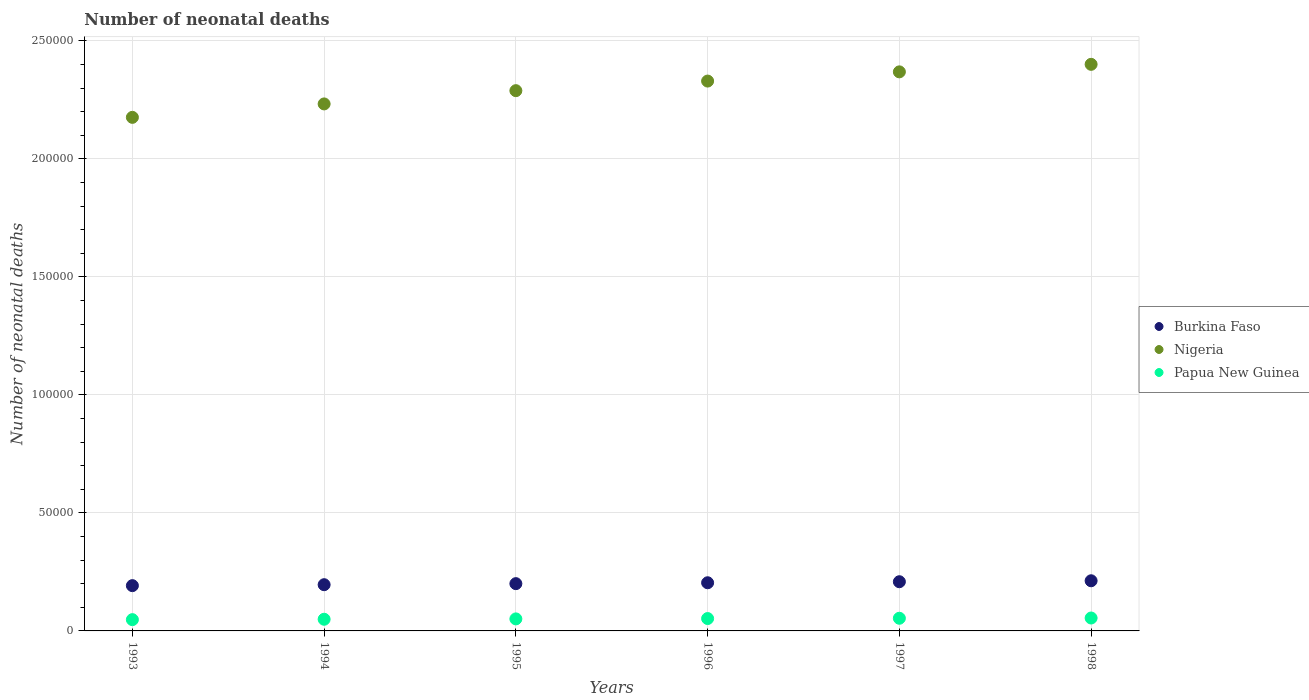How many different coloured dotlines are there?
Offer a terse response. 3. Is the number of dotlines equal to the number of legend labels?
Keep it short and to the point. Yes. What is the number of neonatal deaths in in Nigeria in 1993?
Your response must be concise. 2.18e+05. Across all years, what is the maximum number of neonatal deaths in in Burkina Faso?
Keep it short and to the point. 2.12e+04. Across all years, what is the minimum number of neonatal deaths in in Nigeria?
Offer a very short reply. 2.18e+05. In which year was the number of neonatal deaths in in Burkina Faso minimum?
Your response must be concise. 1993. What is the total number of neonatal deaths in in Papua New Guinea in the graph?
Provide a succinct answer. 3.09e+04. What is the difference between the number of neonatal deaths in in Nigeria in 1997 and that in 1998?
Ensure brevity in your answer.  -3185. What is the difference between the number of neonatal deaths in in Nigeria in 1993 and the number of neonatal deaths in in Papua New Guinea in 1997?
Make the answer very short. 2.12e+05. What is the average number of neonatal deaths in in Nigeria per year?
Keep it short and to the point. 2.30e+05. In the year 1993, what is the difference between the number of neonatal deaths in in Nigeria and number of neonatal deaths in in Papua New Guinea?
Offer a very short reply. 2.13e+05. What is the ratio of the number of neonatal deaths in in Papua New Guinea in 1995 to that in 1997?
Provide a succinct answer. 0.95. Is the number of neonatal deaths in in Burkina Faso in 1995 less than that in 1998?
Your answer should be compact. Yes. Is the difference between the number of neonatal deaths in in Nigeria in 1995 and 1997 greater than the difference between the number of neonatal deaths in in Papua New Guinea in 1995 and 1997?
Provide a short and direct response. No. What is the difference between the highest and the second highest number of neonatal deaths in in Burkina Faso?
Offer a terse response. 403. What is the difference between the highest and the lowest number of neonatal deaths in in Burkina Faso?
Give a very brief answer. 2062. Is the sum of the number of neonatal deaths in in Papua New Guinea in 1994 and 1995 greater than the maximum number of neonatal deaths in in Burkina Faso across all years?
Offer a terse response. No. Does the number of neonatal deaths in in Nigeria monotonically increase over the years?
Make the answer very short. Yes. Is the number of neonatal deaths in in Nigeria strictly greater than the number of neonatal deaths in in Burkina Faso over the years?
Your response must be concise. Yes. Is the number of neonatal deaths in in Papua New Guinea strictly less than the number of neonatal deaths in in Burkina Faso over the years?
Provide a short and direct response. Yes. How many dotlines are there?
Make the answer very short. 3. How many years are there in the graph?
Make the answer very short. 6. Are the values on the major ticks of Y-axis written in scientific E-notation?
Provide a succinct answer. No. Does the graph contain grids?
Make the answer very short. Yes. How many legend labels are there?
Offer a very short reply. 3. What is the title of the graph?
Offer a terse response. Number of neonatal deaths. Does "Madagascar" appear as one of the legend labels in the graph?
Provide a short and direct response. No. What is the label or title of the Y-axis?
Your answer should be very brief. Number of neonatal deaths. What is the Number of neonatal deaths of Burkina Faso in 1993?
Your answer should be very brief. 1.92e+04. What is the Number of neonatal deaths in Nigeria in 1993?
Give a very brief answer. 2.18e+05. What is the Number of neonatal deaths in Papua New Guinea in 1993?
Your answer should be compact. 4776. What is the Number of neonatal deaths in Burkina Faso in 1994?
Your answer should be compact. 1.96e+04. What is the Number of neonatal deaths in Nigeria in 1994?
Provide a short and direct response. 2.23e+05. What is the Number of neonatal deaths in Papua New Guinea in 1994?
Ensure brevity in your answer.  4942. What is the Number of neonatal deaths in Burkina Faso in 1995?
Offer a very short reply. 2.00e+04. What is the Number of neonatal deaths of Nigeria in 1995?
Your answer should be very brief. 2.29e+05. What is the Number of neonatal deaths of Papua New Guinea in 1995?
Provide a succinct answer. 5095. What is the Number of neonatal deaths of Burkina Faso in 1996?
Keep it short and to the point. 2.04e+04. What is the Number of neonatal deaths in Nigeria in 1996?
Keep it short and to the point. 2.33e+05. What is the Number of neonatal deaths of Papua New Guinea in 1996?
Keep it short and to the point. 5244. What is the Number of neonatal deaths in Burkina Faso in 1997?
Your response must be concise. 2.08e+04. What is the Number of neonatal deaths of Nigeria in 1997?
Make the answer very short. 2.37e+05. What is the Number of neonatal deaths of Papua New Guinea in 1997?
Provide a short and direct response. 5367. What is the Number of neonatal deaths in Burkina Faso in 1998?
Your response must be concise. 2.12e+04. What is the Number of neonatal deaths in Nigeria in 1998?
Keep it short and to the point. 2.40e+05. What is the Number of neonatal deaths of Papua New Guinea in 1998?
Offer a very short reply. 5471. Across all years, what is the maximum Number of neonatal deaths of Burkina Faso?
Your answer should be compact. 2.12e+04. Across all years, what is the maximum Number of neonatal deaths in Nigeria?
Give a very brief answer. 2.40e+05. Across all years, what is the maximum Number of neonatal deaths of Papua New Guinea?
Keep it short and to the point. 5471. Across all years, what is the minimum Number of neonatal deaths in Burkina Faso?
Give a very brief answer. 1.92e+04. Across all years, what is the minimum Number of neonatal deaths of Nigeria?
Make the answer very short. 2.18e+05. Across all years, what is the minimum Number of neonatal deaths in Papua New Guinea?
Give a very brief answer. 4776. What is the total Number of neonatal deaths in Burkina Faso in the graph?
Make the answer very short. 1.21e+05. What is the total Number of neonatal deaths of Nigeria in the graph?
Your answer should be compact. 1.38e+06. What is the total Number of neonatal deaths in Papua New Guinea in the graph?
Offer a very short reply. 3.09e+04. What is the difference between the Number of neonatal deaths of Burkina Faso in 1993 and that in 1994?
Your answer should be compact. -399. What is the difference between the Number of neonatal deaths in Nigeria in 1993 and that in 1994?
Offer a terse response. -5689. What is the difference between the Number of neonatal deaths in Papua New Guinea in 1993 and that in 1994?
Keep it short and to the point. -166. What is the difference between the Number of neonatal deaths in Burkina Faso in 1993 and that in 1995?
Make the answer very short. -844. What is the difference between the Number of neonatal deaths of Nigeria in 1993 and that in 1995?
Your answer should be compact. -1.13e+04. What is the difference between the Number of neonatal deaths of Papua New Guinea in 1993 and that in 1995?
Make the answer very short. -319. What is the difference between the Number of neonatal deaths of Burkina Faso in 1993 and that in 1996?
Your answer should be compact. -1220. What is the difference between the Number of neonatal deaths in Nigeria in 1993 and that in 1996?
Your answer should be very brief. -1.54e+04. What is the difference between the Number of neonatal deaths in Papua New Guinea in 1993 and that in 1996?
Provide a short and direct response. -468. What is the difference between the Number of neonatal deaths in Burkina Faso in 1993 and that in 1997?
Give a very brief answer. -1659. What is the difference between the Number of neonatal deaths in Nigeria in 1993 and that in 1997?
Offer a very short reply. -1.93e+04. What is the difference between the Number of neonatal deaths of Papua New Guinea in 1993 and that in 1997?
Ensure brevity in your answer.  -591. What is the difference between the Number of neonatal deaths in Burkina Faso in 1993 and that in 1998?
Keep it short and to the point. -2062. What is the difference between the Number of neonatal deaths of Nigeria in 1993 and that in 1998?
Your answer should be compact. -2.25e+04. What is the difference between the Number of neonatal deaths in Papua New Guinea in 1993 and that in 1998?
Make the answer very short. -695. What is the difference between the Number of neonatal deaths in Burkina Faso in 1994 and that in 1995?
Provide a succinct answer. -445. What is the difference between the Number of neonatal deaths in Nigeria in 1994 and that in 1995?
Your response must be concise. -5616. What is the difference between the Number of neonatal deaths of Papua New Guinea in 1994 and that in 1995?
Keep it short and to the point. -153. What is the difference between the Number of neonatal deaths in Burkina Faso in 1994 and that in 1996?
Provide a short and direct response. -821. What is the difference between the Number of neonatal deaths in Nigeria in 1994 and that in 1996?
Keep it short and to the point. -9683. What is the difference between the Number of neonatal deaths of Papua New Guinea in 1994 and that in 1996?
Provide a short and direct response. -302. What is the difference between the Number of neonatal deaths of Burkina Faso in 1994 and that in 1997?
Make the answer very short. -1260. What is the difference between the Number of neonatal deaths in Nigeria in 1994 and that in 1997?
Your answer should be compact. -1.36e+04. What is the difference between the Number of neonatal deaths in Papua New Guinea in 1994 and that in 1997?
Keep it short and to the point. -425. What is the difference between the Number of neonatal deaths in Burkina Faso in 1994 and that in 1998?
Ensure brevity in your answer.  -1663. What is the difference between the Number of neonatal deaths of Nigeria in 1994 and that in 1998?
Keep it short and to the point. -1.68e+04. What is the difference between the Number of neonatal deaths in Papua New Guinea in 1994 and that in 1998?
Your answer should be compact. -529. What is the difference between the Number of neonatal deaths in Burkina Faso in 1995 and that in 1996?
Offer a terse response. -376. What is the difference between the Number of neonatal deaths of Nigeria in 1995 and that in 1996?
Offer a terse response. -4067. What is the difference between the Number of neonatal deaths of Papua New Guinea in 1995 and that in 1996?
Make the answer very short. -149. What is the difference between the Number of neonatal deaths of Burkina Faso in 1995 and that in 1997?
Keep it short and to the point. -815. What is the difference between the Number of neonatal deaths in Nigeria in 1995 and that in 1997?
Ensure brevity in your answer.  -7971. What is the difference between the Number of neonatal deaths of Papua New Guinea in 1995 and that in 1997?
Provide a short and direct response. -272. What is the difference between the Number of neonatal deaths of Burkina Faso in 1995 and that in 1998?
Your response must be concise. -1218. What is the difference between the Number of neonatal deaths in Nigeria in 1995 and that in 1998?
Your response must be concise. -1.12e+04. What is the difference between the Number of neonatal deaths of Papua New Guinea in 1995 and that in 1998?
Make the answer very short. -376. What is the difference between the Number of neonatal deaths of Burkina Faso in 1996 and that in 1997?
Ensure brevity in your answer.  -439. What is the difference between the Number of neonatal deaths in Nigeria in 1996 and that in 1997?
Your response must be concise. -3904. What is the difference between the Number of neonatal deaths in Papua New Guinea in 1996 and that in 1997?
Your answer should be compact. -123. What is the difference between the Number of neonatal deaths in Burkina Faso in 1996 and that in 1998?
Offer a terse response. -842. What is the difference between the Number of neonatal deaths of Nigeria in 1996 and that in 1998?
Ensure brevity in your answer.  -7089. What is the difference between the Number of neonatal deaths in Papua New Guinea in 1996 and that in 1998?
Your response must be concise. -227. What is the difference between the Number of neonatal deaths of Burkina Faso in 1997 and that in 1998?
Your answer should be compact. -403. What is the difference between the Number of neonatal deaths of Nigeria in 1997 and that in 1998?
Give a very brief answer. -3185. What is the difference between the Number of neonatal deaths of Papua New Guinea in 1997 and that in 1998?
Offer a terse response. -104. What is the difference between the Number of neonatal deaths in Burkina Faso in 1993 and the Number of neonatal deaths in Nigeria in 1994?
Offer a very short reply. -2.04e+05. What is the difference between the Number of neonatal deaths in Burkina Faso in 1993 and the Number of neonatal deaths in Papua New Guinea in 1994?
Provide a succinct answer. 1.42e+04. What is the difference between the Number of neonatal deaths of Nigeria in 1993 and the Number of neonatal deaths of Papua New Guinea in 1994?
Offer a very short reply. 2.13e+05. What is the difference between the Number of neonatal deaths in Burkina Faso in 1993 and the Number of neonatal deaths in Nigeria in 1995?
Keep it short and to the point. -2.10e+05. What is the difference between the Number of neonatal deaths of Burkina Faso in 1993 and the Number of neonatal deaths of Papua New Guinea in 1995?
Provide a short and direct response. 1.41e+04. What is the difference between the Number of neonatal deaths of Nigeria in 1993 and the Number of neonatal deaths of Papua New Guinea in 1995?
Make the answer very short. 2.13e+05. What is the difference between the Number of neonatal deaths in Burkina Faso in 1993 and the Number of neonatal deaths in Nigeria in 1996?
Make the answer very short. -2.14e+05. What is the difference between the Number of neonatal deaths in Burkina Faso in 1993 and the Number of neonatal deaths in Papua New Guinea in 1996?
Give a very brief answer. 1.39e+04. What is the difference between the Number of neonatal deaths of Nigeria in 1993 and the Number of neonatal deaths of Papua New Guinea in 1996?
Offer a terse response. 2.12e+05. What is the difference between the Number of neonatal deaths of Burkina Faso in 1993 and the Number of neonatal deaths of Nigeria in 1997?
Make the answer very short. -2.18e+05. What is the difference between the Number of neonatal deaths in Burkina Faso in 1993 and the Number of neonatal deaths in Papua New Guinea in 1997?
Give a very brief answer. 1.38e+04. What is the difference between the Number of neonatal deaths of Nigeria in 1993 and the Number of neonatal deaths of Papua New Guinea in 1997?
Provide a short and direct response. 2.12e+05. What is the difference between the Number of neonatal deaths of Burkina Faso in 1993 and the Number of neonatal deaths of Nigeria in 1998?
Your answer should be very brief. -2.21e+05. What is the difference between the Number of neonatal deaths of Burkina Faso in 1993 and the Number of neonatal deaths of Papua New Guinea in 1998?
Provide a succinct answer. 1.37e+04. What is the difference between the Number of neonatal deaths in Nigeria in 1993 and the Number of neonatal deaths in Papua New Guinea in 1998?
Make the answer very short. 2.12e+05. What is the difference between the Number of neonatal deaths of Burkina Faso in 1994 and the Number of neonatal deaths of Nigeria in 1995?
Offer a very short reply. -2.09e+05. What is the difference between the Number of neonatal deaths in Burkina Faso in 1994 and the Number of neonatal deaths in Papua New Guinea in 1995?
Your response must be concise. 1.45e+04. What is the difference between the Number of neonatal deaths of Nigeria in 1994 and the Number of neonatal deaths of Papua New Guinea in 1995?
Keep it short and to the point. 2.18e+05. What is the difference between the Number of neonatal deaths in Burkina Faso in 1994 and the Number of neonatal deaths in Nigeria in 1996?
Your answer should be compact. -2.13e+05. What is the difference between the Number of neonatal deaths of Burkina Faso in 1994 and the Number of neonatal deaths of Papua New Guinea in 1996?
Provide a succinct answer. 1.43e+04. What is the difference between the Number of neonatal deaths in Nigeria in 1994 and the Number of neonatal deaths in Papua New Guinea in 1996?
Give a very brief answer. 2.18e+05. What is the difference between the Number of neonatal deaths in Burkina Faso in 1994 and the Number of neonatal deaths in Nigeria in 1997?
Give a very brief answer. -2.17e+05. What is the difference between the Number of neonatal deaths of Burkina Faso in 1994 and the Number of neonatal deaths of Papua New Guinea in 1997?
Ensure brevity in your answer.  1.42e+04. What is the difference between the Number of neonatal deaths in Nigeria in 1994 and the Number of neonatal deaths in Papua New Guinea in 1997?
Provide a short and direct response. 2.18e+05. What is the difference between the Number of neonatal deaths of Burkina Faso in 1994 and the Number of neonatal deaths of Nigeria in 1998?
Provide a short and direct response. -2.20e+05. What is the difference between the Number of neonatal deaths of Burkina Faso in 1994 and the Number of neonatal deaths of Papua New Guinea in 1998?
Offer a very short reply. 1.41e+04. What is the difference between the Number of neonatal deaths of Nigeria in 1994 and the Number of neonatal deaths of Papua New Guinea in 1998?
Ensure brevity in your answer.  2.18e+05. What is the difference between the Number of neonatal deaths of Burkina Faso in 1995 and the Number of neonatal deaths of Nigeria in 1996?
Give a very brief answer. -2.13e+05. What is the difference between the Number of neonatal deaths of Burkina Faso in 1995 and the Number of neonatal deaths of Papua New Guinea in 1996?
Ensure brevity in your answer.  1.48e+04. What is the difference between the Number of neonatal deaths in Nigeria in 1995 and the Number of neonatal deaths in Papua New Guinea in 1996?
Give a very brief answer. 2.24e+05. What is the difference between the Number of neonatal deaths in Burkina Faso in 1995 and the Number of neonatal deaths in Nigeria in 1997?
Make the answer very short. -2.17e+05. What is the difference between the Number of neonatal deaths in Burkina Faso in 1995 and the Number of neonatal deaths in Papua New Guinea in 1997?
Your response must be concise. 1.47e+04. What is the difference between the Number of neonatal deaths in Nigeria in 1995 and the Number of neonatal deaths in Papua New Guinea in 1997?
Make the answer very short. 2.24e+05. What is the difference between the Number of neonatal deaths of Burkina Faso in 1995 and the Number of neonatal deaths of Nigeria in 1998?
Make the answer very short. -2.20e+05. What is the difference between the Number of neonatal deaths of Burkina Faso in 1995 and the Number of neonatal deaths of Papua New Guinea in 1998?
Give a very brief answer. 1.46e+04. What is the difference between the Number of neonatal deaths in Nigeria in 1995 and the Number of neonatal deaths in Papua New Guinea in 1998?
Ensure brevity in your answer.  2.23e+05. What is the difference between the Number of neonatal deaths of Burkina Faso in 1996 and the Number of neonatal deaths of Nigeria in 1997?
Keep it short and to the point. -2.16e+05. What is the difference between the Number of neonatal deaths in Burkina Faso in 1996 and the Number of neonatal deaths in Papua New Guinea in 1997?
Make the answer very short. 1.50e+04. What is the difference between the Number of neonatal deaths of Nigeria in 1996 and the Number of neonatal deaths of Papua New Guinea in 1997?
Your answer should be compact. 2.28e+05. What is the difference between the Number of neonatal deaths of Burkina Faso in 1996 and the Number of neonatal deaths of Nigeria in 1998?
Keep it short and to the point. -2.20e+05. What is the difference between the Number of neonatal deaths of Burkina Faso in 1996 and the Number of neonatal deaths of Papua New Guinea in 1998?
Provide a short and direct response. 1.49e+04. What is the difference between the Number of neonatal deaths in Nigeria in 1996 and the Number of neonatal deaths in Papua New Guinea in 1998?
Keep it short and to the point. 2.28e+05. What is the difference between the Number of neonatal deaths of Burkina Faso in 1997 and the Number of neonatal deaths of Nigeria in 1998?
Make the answer very short. -2.19e+05. What is the difference between the Number of neonatal deaths of Burkina Faso in 1997 and the Number of neonatal deaths of Papua New Guinea in 1998?
Give a very brief answer. 1.54e+04. What is the difference between the Number of neonatal deaths of Nigeria in 1997 and the Number of neonatal deaths of Papua New Guinea in 1998?
Offer a terse response. 2.31e+05. What is the average Number of neonatal deaths of Burkina Faso per year?
Your response must be concise. 2.02e+04. What is the average Number of neonatal deaths in Nigeria per year?
Provide a succinct answer. 2.30e+05. What is the average Number of neonatal deaths in Papua New Guinea per year?
Provide a short and direct response. 5149.17. In the year 1993, what is the difference between the Number of neonatal deaths of Burkina Faso and Number of neonatal deaths of Nigeria?
Offer a very short reply. -1.98e+05. In the year 1993, what is the difference between the Number of neonatal deaths in Burkina Faso and Number of neonatal deaths in Papua New Guinea?
Give a very brief answer. 1.44e+04. In the year 1993, what is the difference between the Number of neonatal deaths in Nigeria and Number of neonatal deaths in Papua New Guinea?
Your answer should be very brief. 2.13e+05. In the year 1994, what is the difference between the Number of neonatal deaths of Burkina Faso and Number of neonatal deaths of Nigeria?
Provide a succinct answer. -2.04e+05. In the year 1994, what is the difference between the Number of neonatal deaths in Burkina Faso and Number of neonatal deaths in Papua New Guinea?
Keep it short and to the point. 1.46e+04. In the year 1994, what is the difference between the Number of neonatal deaths of Nigeria and Number of neonatal deaths of Papua New Guinea?
Give a very brief answer. 2.18e+05. In the year 1995, what is the difference between the Number of neonatal deaths in Burkina Faso and Number of neonatal deaths in Nigeria?
Ensure brevity in your answer.  -2.09e+05. In the year 1995, what is the difference between the Number of neonatal deaths in Burkina Faso and Number of neonatal deaths in Papua New Guinea?
Keep it short and to the point. 1.49e+04. In the year 1995, what is the difference between the Number of neonatal deaths of Nigeria and Number of neonatal deaths of Papua New Guinea?
Your response must be concise. 2.24e+05. In the year 1996, what is the difference between the Number of neonatal deaths of Burkina Faso and Number of neonatal deaths of Nigeria?
Provide a short and direct response. -2.13e+05. In the year 1996, what is the difference between the Number of neonatal deaths of Burkina Faso and Number of neonatal deaths of Papua New Guinea?
Offer a very short reply. 1.52e+04. In the year 1996, what is the difference between the Number of neonatal deaths in Nigeria and Number of neonatal deaths in Papua New Guinea?
Offer a terse response. 2.28e+05. In the year 1997, what is the difference between the Number of neonatal deaths in Burkina Faso and Number of neonatal deaths in Nigeria?
Provide a short and direct response. -2.16e+05. In the year 1997, what is the difference between the Number of neonatal deaths in Burkina Faso and Number of neonatal deaths in Papua New Guinea?
Make the answer very short. 1.55e+04. In the year 1997, what is the difference between the Number of neonatal deaths of Nigeria and Number of neonatal deaths of Papua New Guinea?
Keep it short and to the point. 2.32e+05. In the year 1998, what is the difference between the Number of neonatal deaths in Burkina Faso and Number of neonatal deaths in Nigeria?
Make the answer very short. -2.19e+05. In the year 1998, what is the difference between the Number of neonatal deaths of Burkina Faso and Number of neonatal deaths of Papua New Guinea?
Make the answer very short. 1.58e+04. In the year 1998, what is the difference between the Number of neonatal deaths of Nigeria and Number of neonatal deaths of Papua New Guinea?
Your response must be concise. 2.35e+05. What is the ratio of the Number of neonatal deaths of Burkina Faso in 1993 to that in 1994?
Your answer should be very brief. 0.98. What is the ratio of the Number of neonatal deaths of Nigeria in 1993 to that in 1994?
Provide a short and direct response. 0.97. What is the ratio of the Number of neonatal deaths in Papua New Guinea in 1993 to that in 1994?
Offer a very short reply. 0.97. What is the ratio of the Number of neonatal deaths of Burkina Faso in 1993 to that in 1995?
Keep it short and to the point. 0.96. What is the ratio of the Number of neonatal deaths in Nigeria in 1993 to that in 1995?
Give a very brief answer. 0.95. What is the ratio of the Number of neonatal deaths in Papua New Guinea in 1993 to that in 1995?
Your answer should be compact. 0.94. What is the ratio of the Number of neonatal deaths of Burkina Faso in 1993 to that in 1996?
Provide a short and direct response. 0.94. What is the ratio of the Number of neonatal deaths in Nigeria in 1993 to that in 1996?
Provide a short and direct response. 0.93. What is the ratio of the Number of neonatal deaths in Papua New Guinea in 1993 to that in 1996?
Offer a terse response. 0.91. What is the ratio of the Number of neonatal deaths in Burkina Faso in 1993 to that in 1997?
Keep it short and to the point. 0.92. What is the ratio of the Number of neonatal deaths of Nigeria in 1993 to that in 1997?
Provide a short and direct response. 0.92. What is the ratio of the Number of neonatal deaths of Papua New Guinea in 1993 to that in 1997?
Ensure brevity in your answer.  0.89. What is the ratio of the Number of neonatal deaths of Burkina Faso in 1993 to that in 1998?
Offer a very short reply. 0.9. What is the ratio of the Number of neonatal deaths in Nigeria in 1993 to that in 1998?
Offer a very short reply. 0.91. What is the ratio of the Number of neonatal deaths in Papua New Guinea in 1993 to that in 1998?
Keep it short and to the point. 0.87. What is the ratio of the Number of neonatal deaths in Burkina Faso in 1994 to that in 1995?
Provide a short and direct response. 0.98. What is the ratio of the Number of neonatal deaths in Nigeria in 1994 to that in 1995?
Keep it short and to the point. 0.98. What is the ratio of the Number of neonatal deaths of Burkina Faso in 1994 to that in 1996?
Ensure brevity in your answer.  0.96. What is the ratio of the Number of neonatal deaths of Nigeria in 1994 to that in 1996?
Give a very brief answer. 0.96. What is the ratio of the Number of neonatal deaths in Papua New Guinea in 1994 to that in 1996?
Make the answer very short. 0.94. What is the ratio of the Number of neonatal deaths in Burkina Faso in 1994 to that in 1997?
Provide a short and direct response. 0.94. What is the ratio of the Number of neonatal deaths of Nigeria in 1994 to that in 1997?
Your answer should be very brief. 0.94. What is the ratio of the Number of neonatal deaths of Papua New Guinea in 1994 to that in 1997?
Provide a succinct answer. 0.92. What is the ratio of the Number of neonatal deaths in Burkina Faso in 1994 to that in 1998?
Provide a short and direct response. 0.92. What is the ratio of the Number of neonatal deaths of Nigeria in 1994 to that in 1998?
Ensure brevity in your answer.  0.93. What is the ratio of the Number of neonatal deaths of Papua New Guinea in 1994 to that in 1998?
Provide a short and direct response. 0.9. What is the ratio of the Number of neonatal deaths in Burkina Faso in 1995 to that in 1996?
Keep it short and to the point. 0.98. What is the ratio of the Number of neonatal deaths of Nigeria in 1995 to that in 1996?
Your answer should be compact. 0.98. What is the ratio of the Number of neonatal deaths of Papua New Guinea in 1995 to that in 1996?
Keep it short and to the point. 0.97. What is the ratio of the Number of neonatal deaths of Burkina Faso in 1995 to that in 1997?
Keep it short and to the point. 0.96. What is the ratio of the Number of neonatal deaths of Nigeria in 1995 to that in 1997?
Make the answer very short. 0.97. What is the ratio of the Number of neonatal deaths of Papua New Guinea in 1995 to that in 1997?
Make the answer very short. 0.95. What is the ratio of the Number of neonatal deaths in Burkina Faso in 1995 to that in 1998?
Your answer should be very brief. 0.94. What is the ratio of the Number of neonatal deaths of Nigeria in 1995 to that in 1998?
Offer a very short reply. 0.95. What is the ratio of the Number of neonatal deaths in Papua New Guinea in 1995 to that in 1998?
Make the answer very short. 0.93. What is the ratio of the Number of neonatal deaths in Burkina Faso in 1996 to that in 1997?
Provide a short and direct response. 0.98. What is the ratio of the Number of neonatal deaths in Nigeria in 1996 to that in 1997?
Offer a very short reply. 0.98. What is the ratio of the Number of neonatal deaths of Papua New Guinea in 1996 to that in 1997?
Give a very brief answer. 0.98. What is the ratio of the Number of neonatal deaths of Burkina Faso in 1996 to that in 1998?
Your answer should be very brief. 0.96. What is the ratio of the Number of neonatal deaths of Nigeria in 1996 to that in 1998?
Offer a terse response. 0.97. What is the ratio of the Number of neonatal deaths of Papua New Guinea in 1996 to that in 1998?
Provide a short and direct response. 0.96. What is the ratio of the Number of neonatal deaths in Burkina Faso in 1997 to that in 1998?
Offer a very short reply. 0.98. What is the ratio of the Number of neonatal deaths of Nigeria in 1997 to that in 1998?
Give a very brief answer. 0.99. What is the ratio of the Number of neonatal deaths in Papua New Guinea in 1997 to that in 1998?
Make the answer very short. 0.98. What is the difference between the highest and the second highest Number of neonatal deaths of Burkina Faso?
Provide a short and direct response. 403. What is the difference between the highest and the second highest Number of neonatal deaths of Nigeria?
Offer a very short reply. 3185. What is the difference between the highest and the second highest Number of neonatal deaths in Papua New Guinea?
Your answer should be very brief. 104. What is the difference between the highest and the lowest Number of neonatal deaths of Burkina Faso?
Give a very brief answer. 2062. What is the difference between the highest and the lowest Number of neonatal deaths in Nigeria?
Your answer should be very brief. 2.25e+04. What is the difference between the highest and the lowest Number of neonatal deaths in Papua New Guinea?
Keep it short and to the point. 695. 